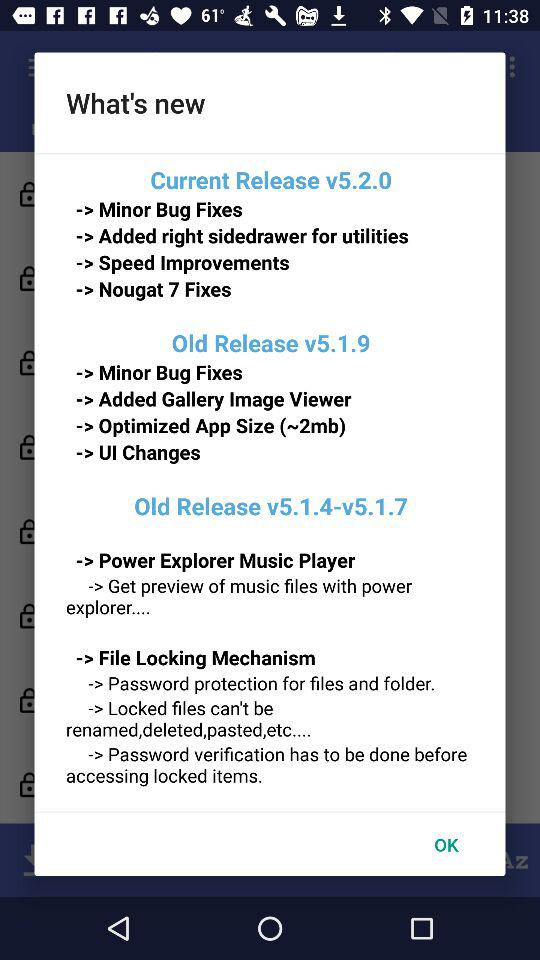What is the current version number? The current version number is v5.2.0. 